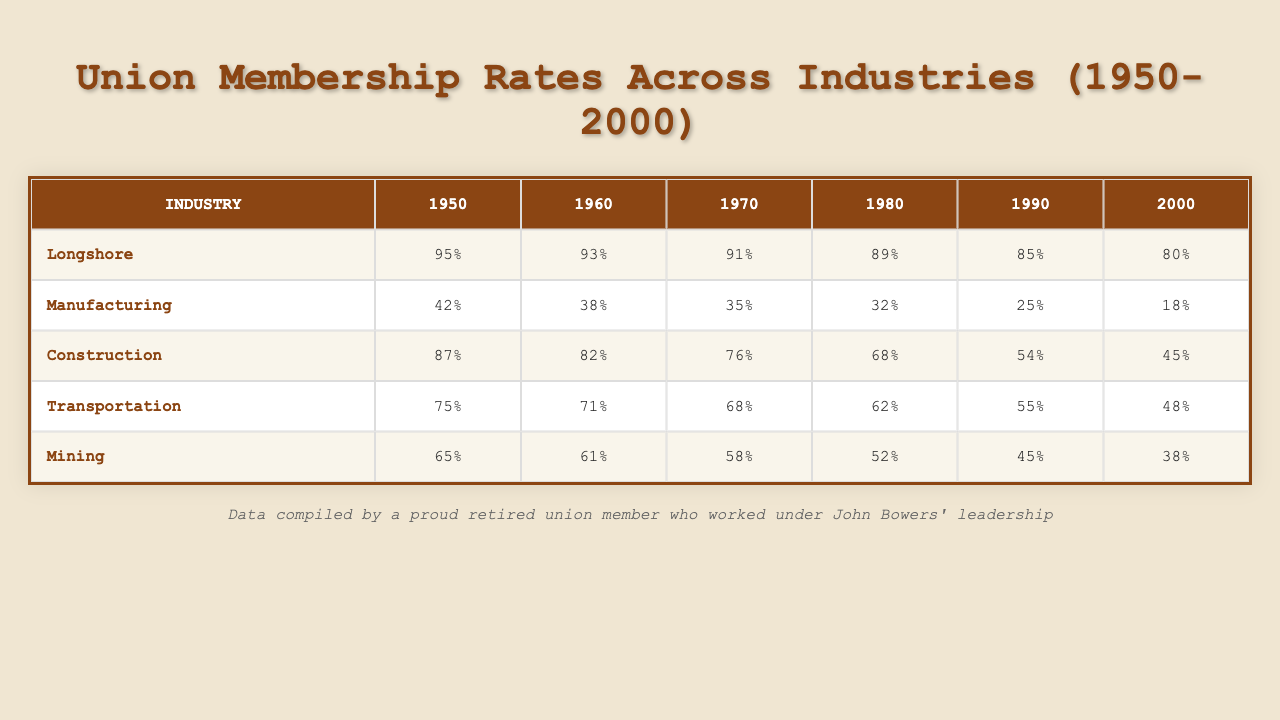What was the union membership rate for the Longshore industry in 1980? According to the table, the Longshore industry had a membership rate of 89% in 1980.
Answer: 89% Which industry had the highest union membership rate in 1950? Looking at the table, the Longshore industry had the highest membership rate of 95% in 1950.
Answer: Longshore In which decade did the Manufacturing industry's membership decline the most? The largest decline in the Manufacturing industry appears between 1950 and 1960, where it dropped from 42% to 38%, which is a 4% decline; however, the steepest decline is from 1980 to 1990, where it dropped from 32% to 25%, a 7% decline. This indicates the most significant drop occurred in the 1980s.
Answer: 1980s What is the average membership rate for the Construction industry across all the years? To compute the average, we sum the membership rates: 87 + 82 + 76 + 68 + 54 + 45 = 412. There are 6 years, so we divide by 6, giving us an average membership rate of 412 / 6 = 68.67.
Answer: 68.67 Did the Mining industry ever have a membership rate higher than 60%? By examining the table, we can see that the Mining industry's membership rate was above 60% in 1950 (65%) and 1960 (61%), confirming that it did.
Answer: Yes Which two industries had the most similar membership rates in 2000? In 2000, the Mining industry had a membership rate of 38%, while the Construction industry was at 45%. The difference is 7%, indicating they were the most similar by rate in that year.
Answer: Construction and Mining What was the overall trend in union membership for the Transportation industry from 1950 to 2000? The Transportation industry started at 75% in 1950 and steadily declined to 48% by 2000, showing a downward trend in union membership over the 50-year period.
Answer: Downward trend What was the total decline in union membership rate for the Manufacturing industry from 1950 to 2000? The Manufacturing industry began at 42% in 1950 and ended at 18% in 2000, a total decline of 24%. To find this, we subtract 18 from 42, resulting in 24.
Answer: 24% decline In 1990, which industry had a membership rate closest to 50%? Reviewing the table, the Construction industry had a membership rate of 54% in 1990, which is the closest to 50%.
Answer: Construction How many industries had a membership rate above 80% in 1960? The Longshore and Construction industries had membership rates of 93% and 82% respectively in 1960. Therefore, two industries were above this threshold.
Answer: 2 industries 